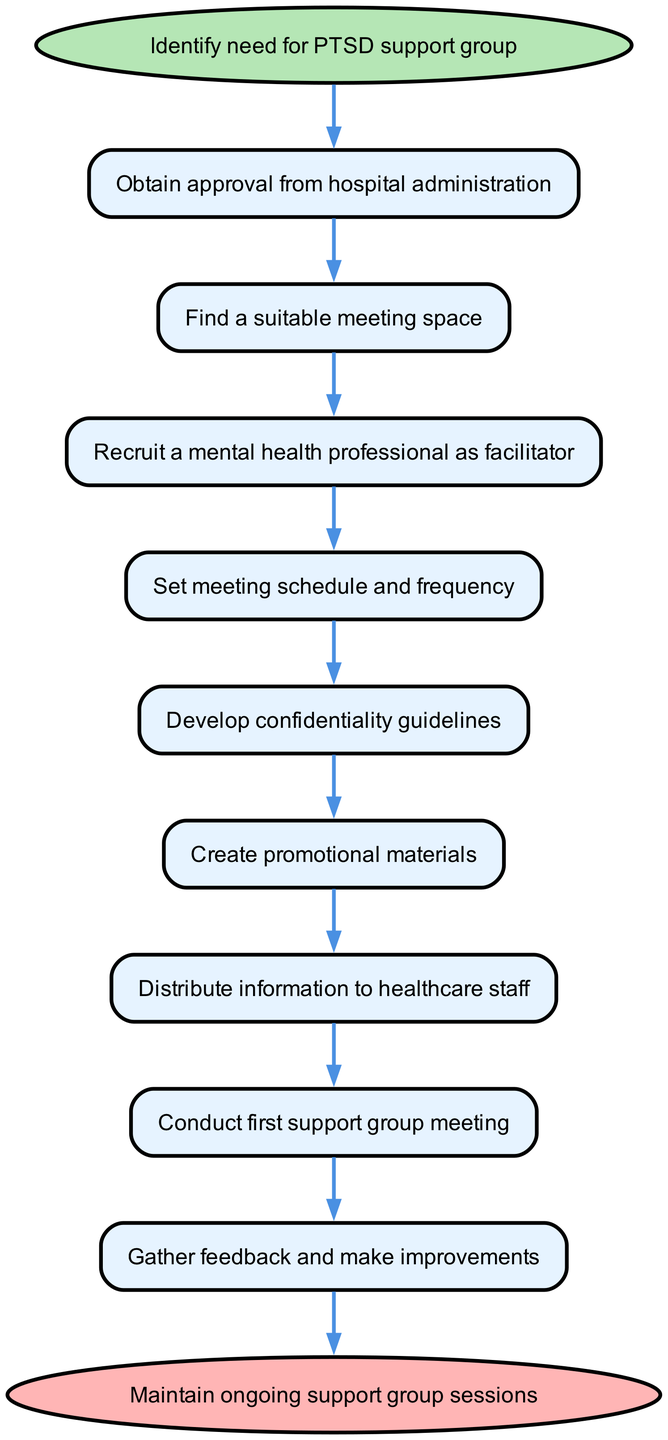What is the first step in the process? The diagram starts with the node labeled "Identify need for PTSD support group," indicating that this is the initial action in the procedure.
Answer: Identify need for PTSD support group How many steps are there from start to end? By counting the nodes in the flow from the start node to the end node, we find there are 9 steps (excluding the start and end nodes themselves).
Answer: 9 steps What step comes after obtaining approval from hospital administration? The flow chart indicates that the next step after "Obtain approval from hospital administration" is "Find a suitable meeting space."
Answer: Find a suitable meeting space What must be developed before promotional materials are created? According to the flow chart, "Develop confidentiality guidelines" must be completed before moving on to create promotional materials.
Answer: Develop confidentiality guidelines Is there a step for gathering feedback? Yes, the diagram includes a step labeled "Gather feedback and make improvements," which occurs after conducting the first support group meeting.
Answer: Yes Which node indicates the completion of the process? The final node in the flow chart, labeled "Maintain ongoing support group sessions," indicates the end of the process.
Answer: Maintain ongoing support group sessions What role should be recruited in step 3? Step 3 specifies that a "mental health professional" should be recruited to facilitate the group.
Answer: Mental health professional What is the connection between setting the meeting schedule and developing confidentiality guidelines? The diagram shows that "Set meeting schedule and frequency" follows "Develop confidentiality guidelines," meaning the meeting schedule comes after this guideline is developed.
Answer: Set meeting schedule and frequency What action should be taken after the first support group meeting? After conducting the first support group meeting, the next action is to "Gather feedback and make improvements."
Answer: Gather feedback and make improvements 